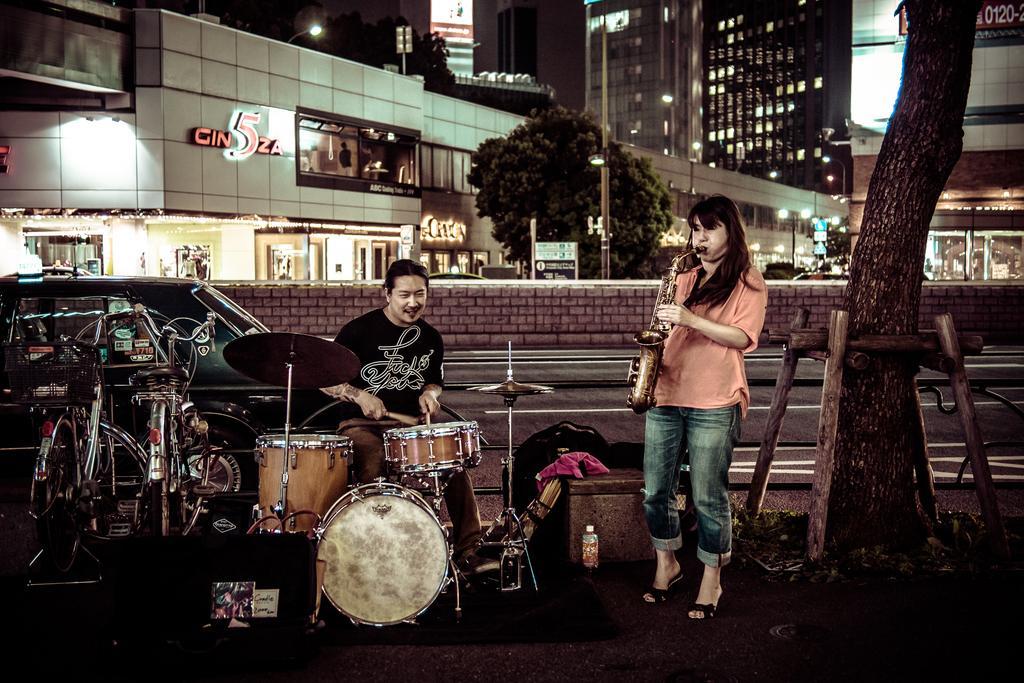Could you give a brief overview of what you see in this image? The women in the right is playing Saxophone and the person beside her is playing drums and there are two cycles beside him and there are buildings and trees behind them. 